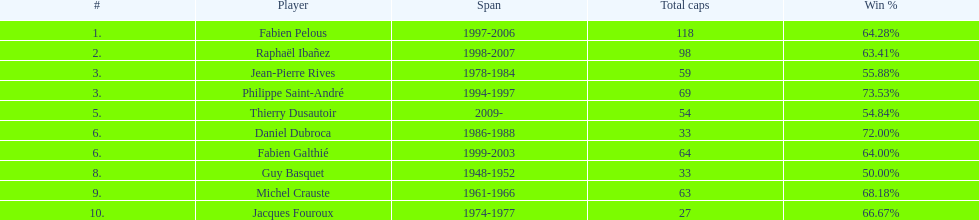How long did fabien pelous serve as captain in the french national rugby team? 9 years. 